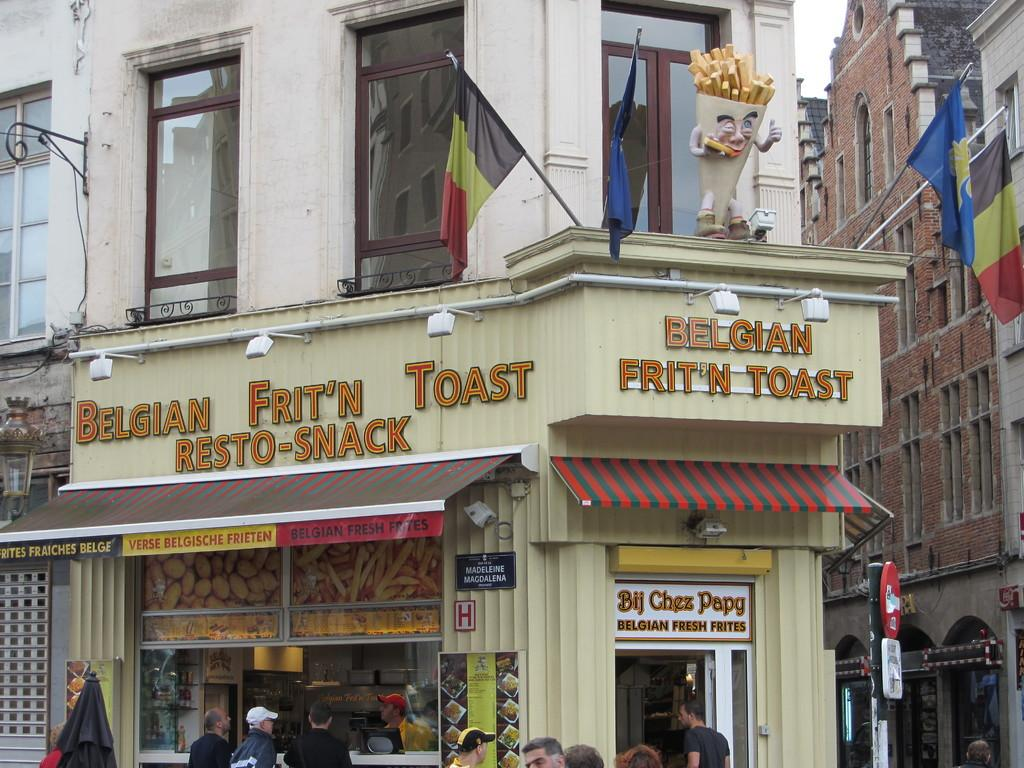What is located in the center of the image? There are two flags on a building in the center of the image. What can be seen on the right side of the image? There is a building and a pole on the right side of the image. Who or what is visible at the bottom of the image? A group of people is visible at the bottom of the image. What type of branch can be seen sticking out of the tongue of one of the people in the image? There is no branch or tongue visible in the image; it only features two flags on a building, a building and a pole on the right side, and a group of people at the bottom. 